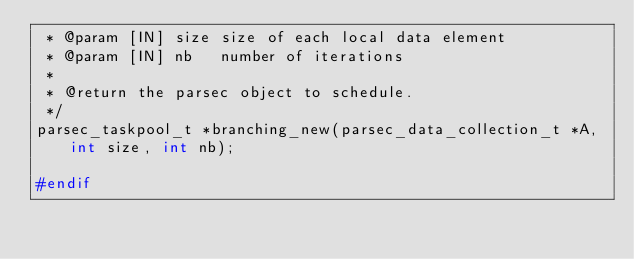Convert code to text. <code><loc_0><loc_0><loc_500><loc_500><_C_> * @param [IN] size size of each local data element
 * @param [IN] nb   number of iterations
 *
 * @return the parsec object to schedule.
 */
parsec_taskpool_t *branching_new(parsec_data_collection_t *A, int size, int nb);

#endif
</code> 